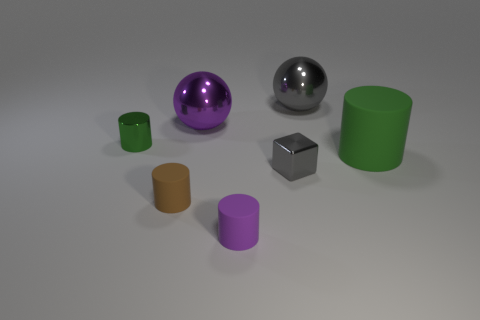Are there more green rubber cylinders than large gray cubes?
Ensure brevity in your answer.  Yes. The cube that is made of the same material as the big gray object is what size?
Make the answer very short. Small. What is the material of the tiny green cylinder?
Your answer should be compact. Metal. What number of metallic objects are the same size as the cube?
Your response must be concise. 1. There is a large object that is the same color as the small metal cube; what is its shape?
Give a very brief answer. Sphere. Are there any purple matte things of the same shape as the brown object?
Your answer should be very brief. Yes. The block that is the same size as the brown rubber cylinder is what color?
Your response must be concise. Gray. What color is the cylinder behind the cylinder that is to the right of the gray block?
Provide a succinct answer. Green. There is a large metal object to the right of the small gray object; does it have the same color as the small cube?
Make the answer very short. Yes. The rubber thing that is in front of the tiny brown thing in front of the green cylinder on the right side of the gray ball is what shape?
Make the answer very short. Cylinder. 